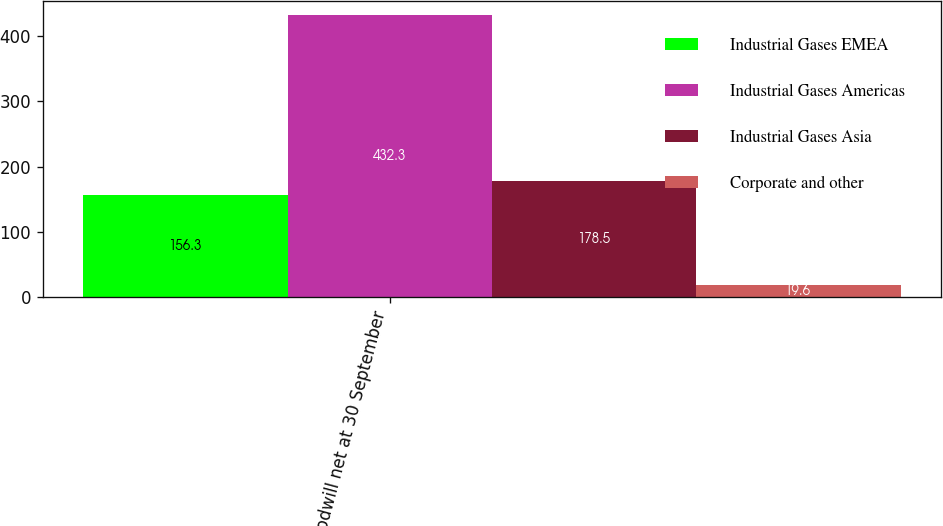Convert chart to OTSL. <chart><loc_0><loc_0><loc_500><loc_500><stacked_bar_chart><ecel><fcel>Goodwill net at 30 September<nl><fcel>Industrial Gases EMEA<fcel>156.3<nl><fcel>Industrial Gases Americas<fcel>432.3<nl><fcel>Industrial Gases Asia<fcel>178.5<nl><fcel>Corporate and other<fcel>19.6<nl></chart> 